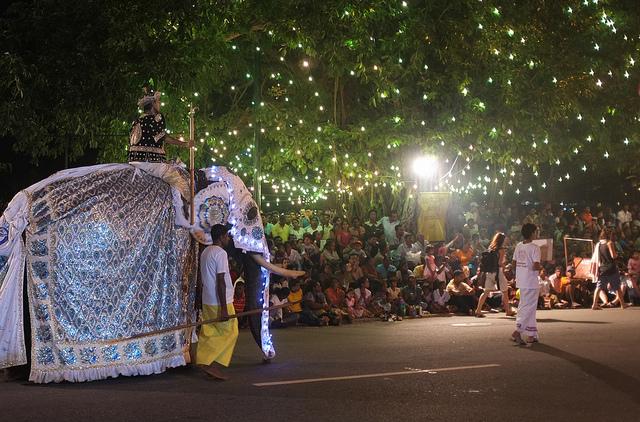What circus do they work for?
Give a very brief answer. Ringling. Are there any spectators?
Write a very short answer. Yes. Are the lights on?
Short answer required. Yes. What state flag is similar to an image in this picture?
Give a very brief answer. None. What colors are on the elephant?
Answer briefly. Blue and silver. Where is this?
Be succinct. India. 